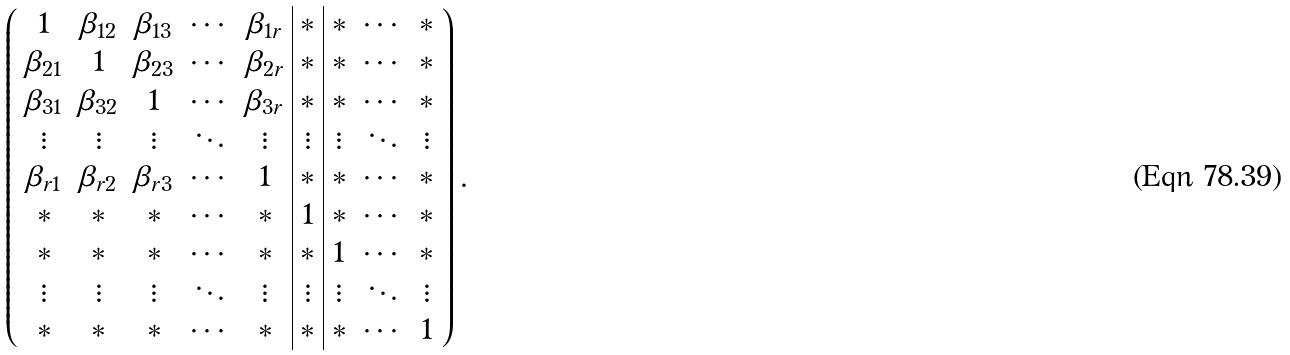Convert formula to latex. <formula><loc_0><loc_0><loc_500><loc_500>\left ( \begin{array} { c c c c c | c | c c c } 1 & \beta _ { 1 2 } & \beta _ { 1 3 } & \cdots & \beta _ { 1 r } & * & * & \cdots & * \\ \beta _ { 2 1 } & 1 & \beta _ { 2 3 } & \cdots & \beta _ { 2 r } & * & * & \cdots & * \\ \beta _ { 3 1 } & \beta _ { 3 2 } & 1 & \cdots & \beta _ { 3 r } & * & * & \cdots & * \\ \vdots & \vdots & \vdots & \ddots & \vdots & \vdots & \vdots & \ddots & \vdots \\ \beta _ { r 1 } & \beta _ { r 2 } & \beta _ { r 3 } & \cdots & 1 & * & * & \cdots & * \\ * & * & * & \cdots & * & 1 & * & \cdots & * \\ * & * & * & \cdots & * & * & 1 & \cdots & * \\ \vdots & \vdots & \vdots & \ddots & \vdots & \vdots & \vdots & \ddots & \vdots \\ * & * & * & \cdots & * & * & * & \cdots & 1 \\ \end{array} \right ) .</formula> 